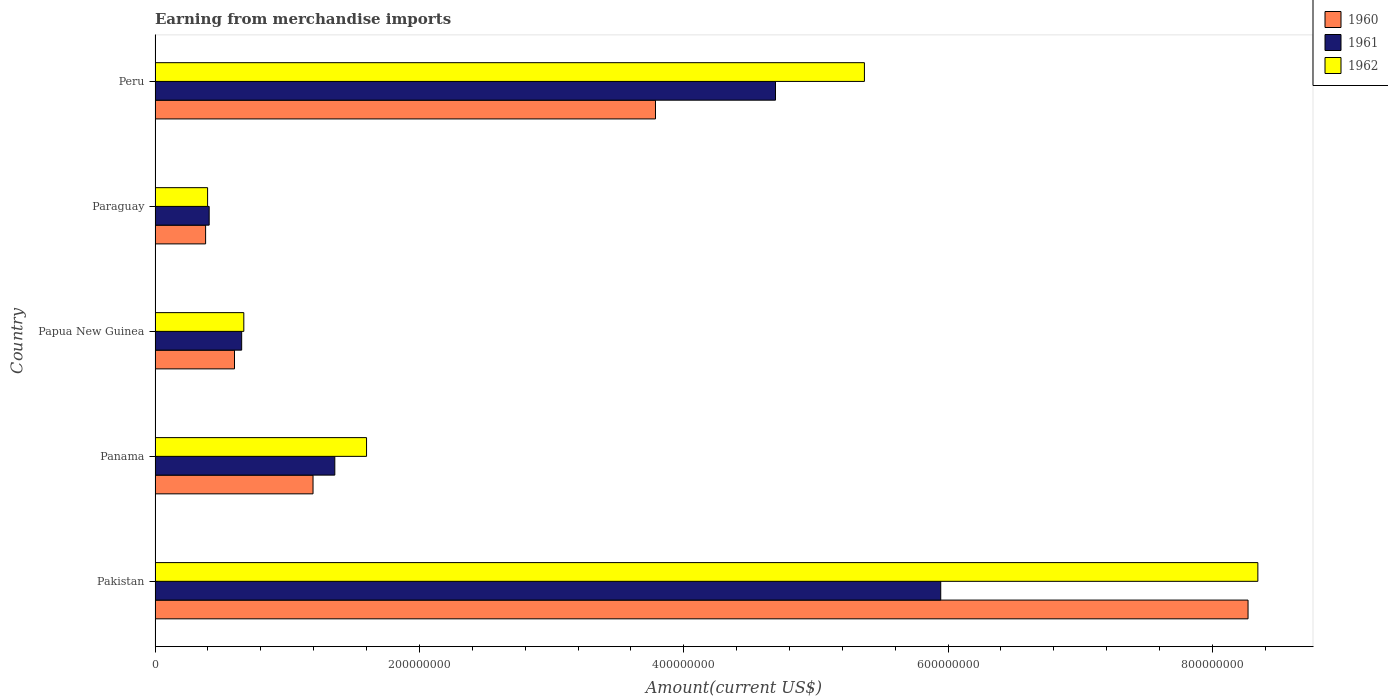How many different coloured bars are there?
Provide a short and direct response. 3. Are the number of bars per tick equal to the number of legend labels?
Give a very brief answer. Yes. How many bars are there on the 1st tick from the top?
Your response must be concise. 3. In how many cases, is the number of bars for a given country not equal to the number of legend labels?
Your answer should be very brief. 0. What is the amount earned from merchandise imports in 1960 in Papua New Guinea?
Offer a terse response. 6.01e+07. Across all countries, what is the maximum amount earned from merchandise imports in 1962?
Make the answer very short. 8.34e+08. Across all countries, what is the minimum amount earned from merchandise imports in 1960?
Ensure brevity in your answer.  3.82e+07. In which country was the amount earned from merchandise imports in 1962 minimum?
Keep it short and to the point. Paraguay. What is the total amount earned from merchandise imports in 1961 in the graph?
Your answer should be compact. 1.31e+09. What is the difference between the amount earned from merchandise imports in 1961 in Panama and that in Peru?
Make the answer very short. -3.33e+08. What is the difference between the amount earned from merchandise imports in 1960 in Panama and the amount earned from merchandise imports in 1962 in Paraguay?
Provide a succinct answer. 7.98e+07. What is the average amount earned from merchandise imports in 1961 per country?
Provide a short and direct response. 2.61e+08. What is the difference between the amount earned from merchandise imports in 1961 and amount earned from merchandise imports in 1960 in Papua New Guinea?
Give a very brief answer. 5.42e+06. What is the ratio of the amount earned from merchandise imports in 1960 in Panama to that in Peru?
Offer a terse response. 0.32. Is the difference between the amount earned from merchandise imports in 1961 in Pakistan and Panama greater than the difference between the amount earned from merchandise imports in 1960 in Pakistan and Panama?
Your answer should be very brief. No. What is the difference between the highest and the second highest amount earned from merchandise imports in 1962?
Offer a terse response. 2.98e+08. What is the difference between the highest and the lowest amount earned from merchandise imports in 1960?
Keep it short and to the point. 7.89e+08. What does the 1st bar from the top in Pakistan represents?
Offer a terse response. 1962. What does the 2nd bar from the bottom in Peru represents?
Your response must be concise. 1961. Is it the case that in every country, the sum of the amount earned from merchandise imports in 1960 and amount earned from merchandise imports in 1961 is greater than the amount earned from merchandise imports in 1962?
Your response must be concise. Yes. What is the difference between two consecutive major ticks on the X-axis?
Provide a short and direct response. 2.00e+08. Does the graph contain grids?
Your answer should be very brief. No. What is the title of the graph?
Your answer should be compact. Earning from merchandise imports. What is the label or title of the X-axis?
Provide a succinct answer. Amount(current US$). What is the Amount(current US$) in 1960 in Pakistan?
Your answer should be compact. 8.27e+08. What is the Amount(current US$) in 1961 in Pakistan?
Provide a succinct answer. 5.94e+08. What is the Amount(current US$) in 1962 in Pakistan?
Keep it short and to the point. 8.34e+08. What is the Amount(current US$) in 1960 in Panama?
Provide a succinct answer. 1.20e+08. What is the Amount(current US$) of 1961 in Panama?
Your response must be concise. 1.36e+08. What is the Amount(current US$) of 1962 in Panama?
Ensure brevity in your answer.  1.60e+08. What is the Amount(current US$) of 1960 in Papua New Guinea?
Provide a succinct answer. 6.01e+07. What is the Amount(current US$) of 1961 in Papua New Guinea?
Give a very brief answer. 6.55e+07. What is the Amount(current US$) of 1962 in Papua New Guinea?
Offer a terse response. 6.71e+07. What is the Amount(current US$) of 1960 in Paraguay?
Your answer should be very brief. 3.82e+07. What is the Amount(current US$) in 1961 in Paraguay?
Ensure brevity in your answer.  4.09e+07. What is the Amount(current US$) of 1962 in Paraguay?
Keep it short and to the point. 3.97e+07. What is the Amount(current US$) of 1960 in Peru?
Ensure brevity in your answer.  3.79e+08. What is the Amount(current US$) of 1961 in Peru?
Provide a short and direct response. 4.69e+08. What is the Amount(current US$) in 1962 in Peru?
Your answer should be compact. 5.37e+08. Across all countries, what is the maximum Amount(current US$) of 1960?
Keep it short and to the point. 8.27e+08. Across all countries, what is the maximum Amount(current US$) of 1961?
Your answer should be very brief. 5.94e+08. Across all countries, what is the maximum Amount(current US$) of 1962?
Offer a terse response. 8.34e+08. Across all countries, what is the minimum Amount(current US$) in 1960?
Give a very brief answer. 3.82e+07. Across all countries, what is the minimum Amount(current US$) in 1961?
Your response must be concise. 4.09e+07. Across all countries, what is the minimum Amount(current US$) of 1962?
Make the answer very short. 3.97e+07. What is the total Amount(current US$) in 1960 in the graph?
Give a very brief answer. 1.42e+09. What is the total Amount(current US$) of 1961 in the graph?
Provide a short and direct response. 1.31e+09. What is the total Amount(current US$) in 1962 in the graph?
Offer a very short reply. 1.64e+09. What is the difference between the Amount(current US$) of 1960 in Pakistan and that in Panama?
Your answer should be compact. 7.07e+08. What is the difference between the Amount(current US$) of 1961 in Pakistan and that in Panama?
Make the answer very short. 4.58e+08. What is the difference between the Amount(current US$) of 1962 in Pakistan and that in Panama?
Provide a short and direct response. 6.74e+08. What is the difference between the Amount(current US$) in 1960 in Pakistan and that in Papua New Guinea?
Your answer should be very brief. 7.67e+08. What is the difference between the Amount(current US$) in 1961 in Pakistan and that in Papua New Guinea?
Give a very brief answer. 5.29e+08. What is the difference between the Amount(current US$) of 1962 in Pakistan and that in Papua New Guinea?
Give a very brief answer. 7.67e+08. What is the difference between the Amount(current US$) in 1960 in Pakistan and that in Paraguay?
Your answer should be compact. 7.89e+08. What is the difference between the Amount(current US$) in 1961 in Pakistan and that in Paraguay?
Give a very brief answer. 5.53e+08. What is the difference between the Amount(current US$) of 1962 in Pakistan and that in Paraguay?
Your response must be concise. 7.95e+08. What is the difference between the Amount(current US$) in 1960 in Pakistan and that in Peru?
Offer a very short reply. 4.48e+08. What is the difference between the Amount(current US$) in 1961 in Pakistan and that in Peru?
Your answer should be compact. 1.25e+08. What is the difference between the Amount(current US$) of 1962 in Pakistan and that in Peru?
Offer a terse response. 2.98e+08. What is the difference between the Amount(current US$) in 1960 in Panama and that in Papua New Guinea?
Offer a very short reply. 5.94e+07. What is the difference between the Amount(current US$) in 1961 in Panama and that in Papua New Guinea?
Offer a very short reply. 7.05e+07. What is the difference between the Amount(current US$) of 1962 in Panama and that in Papua New Guinea?
Your response must be concise. 9.29e+07. What is the difference between the Amount(current US$) in 1960 in Panama and that in Paraguay?
Provide a succinct answer. 8.13e+07. What is the difference between the Amount(current US$) in 1961 in Panama and that in Paraguay?
Give a very brief answer. 9.51e+07. What is the difference between the Amount(current US$) of 1962 in Panama and that in Paraguay?
Your answer should be very brief. 1.20e+08. What is the difference between the Amount(current US$) in 1960 in Panama and that in Peru?
Give a very brief answer. -2.59e+08. What is the difference between the Amount(current US$) of 1961 in Panama and that in Peru?
Offer a very short reply. -3.33e+08. What is the difference between the Amount(current US$) of 1962 in Panama and that in Peru?
Keep it short and to the point. -3.77e+08. What is the difference between the Amount(current US$) in 1960 in Papua New Guinea and that in Paraguay?
Offer a terse response. 2.19e+07. What is the difference between the Amount(current US$) in 1961 in Papua New Guinea and that in Paraguay?
Your answer should be compact. 2.46e+07. What is the difference between the Amount(current US$) in 1962 in Papua New Guinea and that in Paraguay?
Provide a short and direct response. 2.74e+07. What is the difference between the Amount(current US$) in 1960 in Papua New Guinea and that in Peru?
Provide a succinct answer. -3.18e+08. What is the difference between the Amount(current US$) in 1961 in Papua New Guinea and that in Peru?
Give a very brief answer. -4.04e+08. What is the difference between the Amount(current US$) in 1962 in Papua New Guinea and that in Peru?
Give a very brief answer. -4.70e+08. What is the difference between the Amount(current US$) in 1960 in Paraguay and that in Peru?
Offer a terse response. -3.40e+08. What is the difference between the Amount(current US$) in 1961 in Paraguay and that in Peru?
Keep it short and to the point. -4.28e+08. What is the difference between the Amount(current US$) of 1962 in Paraguay and that in Peru?
Your answer should be compact. -4.97e+08. What is the difference between the Amount(current US$) in 1960 in Pakistan and the Amount(current US$) in 1961 in Panama?
Ensure brevity in your answer.  6.91e+08. What is the difference between the Amount(current US$) in 1960 in Pakistan and the Amount(current US$) in 1962 in Panama?
Keep it short and to the point. 6.67e+08. What is the difference between the Amount(current US$) of 1961 in Pakistan and the Amount(current US$) of 1962 in Panama?
Give a very brief answer. 4.34e+08. What is the difference between the Amount(current US$) in 1960 in Pakistan and the Amount(current US$) in 1961 in Papua New Guinea?
Make the answer very short. 7.61e+08. What is the difference between the Amount(current US$) of 1960 in Pakistan and the Amount(current US$) of 1962 in Papua New Guinea?
Provide a succinct answer. 7.60e+08. What is the difference between the Amount(current US$) of 1961 in Pakistan and the Amount(current US$) of 1962 in Papua New Guinea?
Provide a short and direct response. 5.27e+08. What is the difference between the Amount(current US$) of 1960 in Pakistan and the Amount(current US$) of 1961 in Paraguay?
Keep it short and to the point. 7.86e+08. What is the difference between the Amount(current US$) of 1960 in Pakistan and the Amount(current US$) of 1962 in Paraguay?
Provide a succinct answer. 7.87e+08. What is the difference between the Amount(current US$) in 1961 in Pakistan and the Amount(current US$) in 1962 in Paraguay?
Your response must be concise. 5.55e+08. What is the difference between the Amount(current US$) of 1960 in Pakistan and the Amount(current US$) of 1961 in Peru?
Your response must be concise. 3.58e+08. What is the difference between the Amount(current US$) in 1960 in Pakistan and the Amount(current US$) in 1962 in Peru?
Your response must be concise. 2.90e+08. What is the difference between the Amount(current US$) in 1961 in Pakistan and the Amount(current US$) in 1962 in Peru?
Keep it short and to the point. 5.77e+07. What is the difference between the Amount(current US$) in 1960 in Panama and the Amount(current US$) in 1961 in Papua New Guinea?
Offer a terse response. 5.40e+07. What is the difference between the Amount(current US$) in 1960 in Panama and the Amount(current US$) in 1962 in Papua New Guinea?
Ensure brevity in your answer.  5.24e+07. What is the difference between the Amount(current US$) of 1961 in Panama and the Amount(current US$) of 1962 in Papua New Guinea?
Provide a short and direct response. 6.89e+07. What is the difference between the Amount(current US$) of 1960 in Panama and the Amount(current US$) of 1961 in Paraguay?
Provide a succinct answer. 7.86e+07. What is the difference between the Amount(current US$) in 1960 in Panama and the Amount(current US$) in 1962 in Paraguay?
Make the answer very short. 7.98e+07. What is the difference between the Amount(current US$) in 1961 in Panama and the Amount(current US$) in 1962 in Paraguay?
Make the answer very short. 9.63e+07. What is the difference between the Amount(current US$) of 1960 in Panama and the Amount(current US$) of 1961 in Peru?
Your answer should be compact. -3.50e+08. What is the difference between the Amount(current US$) of 1960 in Panama and the Amount(current US$) of 1962 in Peru?
Offer a terse response. -4.17e+08. What is the difference between the Amount(current US$) in 1961 in Panama and the Amount(current US$) in 1962 in Peru?
Provide a succinct answer. -4.01e+08. What is the difference between the Amount(current US$) in 1960 in Papua New Guinea and the Amount(current US$) in 1961 in Paraguay?
Offer a terse response. 1.92e+07. What is the difference between the Amount(current US$) of 1960 in Papua New Guinea and the Amount(current US$) of 1962 in Paraguay?
Provide a succinct answer. 2.04e+07. What is the difference between the Amount(current US$) of 1961 in Papua New Guinea and the Amount(current US$) of 1962 in Paraguay?
Offer a terse response. 2.58e+07. What is the difference between the Amount(current US$) of 1960 in Papua New Guinea and the Amount(current US$) of 1961 in Peru?
Your response must be concise. -4.09e+08. What is the difference between the Amount(current US$) in 1960 in Papua New Guinea and the Amount(current US$) in 1962 in Peru?
Provide a short and direct response. -4.77e+08. What is the difference between the Amount(current US$) in 1961 in Papua New Guinea and the Amount(current US$) in 1962 in Peru?
Your response must be concise. -4.71e+08. What is the difference between the Amount(current US$) of 1960 in Paraguay and the Amount(current US$) of 1961 in Peru?
Provide a succinct answer. -4.31e+08. What is the difference between the Amount(current US$) in 1960 in Paraguay and the Amount(current US$) in 1962 in Peru?
Your response must be concise. -4.98e+08. What is the difference between the Amount(current US$) of 1961 in Paraguay and the Amount(current US$) of 1962 in Peru?
Offer a terse response. -4.96e+08. What is the average Amount(current US$) in 1960 per country?
Your answer should be very brief. 2.85e+08. What is the average Amount(current US$) in 1961 per country?
Provide a short and direct response. 2.61e+08. What is the average Amount(current US$) in 1962 per country?
Your response must be concise. 3.28e+08. What is the difference between the Amount(current US$) of 1960 and Amount(current US$) of 1961 in Pakistan?
Give a very brief answer. 2.33e+08. What is the difference between the Amount(current US$) in 1960 and Amount(current US$) in 1962 in Pakistan?
Give a very brief answer. -7.41e+06. What is the difference between the Amount(current US$) in 1961 and Amount(current US$) in 1962 in Pakistan?
Offer a very short reply. -2.40e+08. What is the difference between the Amount(current US$) of 1960 and Amount(current US$) of 1961 in Panama?
Provide a succinct answer. -1.65e+07. What is the difference between the Amount(current US$) in 1960 and Amount(current US$) in 1962 in Panama?
Give a very brief answer. -4.05e+07. What is the difference between the Amount(current US$) of 1961 and Amount(current US$) of 1962 in Panama?
Provide a short and direct response. -2.40e+07. What is the difference between the Amount(current US$) of 1960 and Amount(current US$) of 1961 in Papua New Guinea?
Provide a succinct answer. -5.42e+06. What is the difference between the Amount(current US$) of 1960 and Amount(current US$) of 1962 in Papua New Guinea?
Provide a succinct answer. -7.04e+06. What is the difference between the Amount(current US$) of 1961 and Amount(current US$) of 1962 in Papua New Guinea?
Your response must be concise. -1.62e+06. What is the difference between the Amount(current US$) in 1960 and Amount(current US$) in 1961 in Paraguay?
Give a very brief answer. -2.70e+06. What is the difference between the Amount(current US$) of 1960 and Amount(current US$) of 1962 in Paraguay?
Offer a terse response. -1.50e+06. What is the difference between the Amount(current US$) in 1961 and Amount(current US$) in 1962 in Paraguay?
Offer a very short reply. 1.20e+06. What is the difference between the Amount(current US$) in 1960 and Amount(current US$) in 1961 in Peru?
Your answer should be compact. -9.08e+07. What is the difference between the Amount(current US$) in 1960 and Amount(current US$) in 1962 in Peru?
Keep it short and to the point. -1.58e+08. What is the difference between the Amount(current US$) of 1961 and Amount(current US$) of 1962 in Peru?
Your answer should be compact. -6.73e+07. What is the ratio of the Amount(current US$) of 1960 in Pakistan to that in Panama?
Offer a very short reply. 6.92. What is the ratio of the Amount(current US$) in 1961 in Pakistan to that in Panama?
Offer a very short reply. 4.37. What is the ratio of the Amount(current US$) in 1962 in Pakistan to that in Panama?
Provide a short and direct response. 5.21. What is the ratio of the Amount(current US$) of 1960 in Pakistan to that in Papua New Guinea?
Offer a very short reply. 13.76. What is the ratio of the Amount(current US$) in 1961 in Pakistan to that in Papua New Guinea?
Your answer should be compact. 9.07. What is the ratio of the Amount(current US$) of 1962 in Pakistan to that in Papua New Guinea?
Your answer should be compact. 12.43. What is the ratio of the Amount(current US$) of 1960 in Pakistan to that in Paraguay?
Your answer should be very brief. 21.62. What is the ratio of the Amount(current US$) in 1961 in Pakistan to that in Paraguay?
Ensure brevity in your answer.  14.52. What is the ratio of the Amount(current US$) of 1962 in Pakistan to that in Paraguay?
Your response must be concise. 20.99. What is the ratio of the Amount(current US$) of 1960 in Pakistan to that in Peru?
Your response must be concise. 2.18. What is the ratio of the Amount(current US$) of 1961 in Pakistan to that in Peru?
Your answer should be very brief. 1.27. What is the ratio of the Amount(current US$) in 1962 in Pakistan to that in Peru?
Make the answer very short. 1.55. What is the ratio of the Amount(current US$) of 1960 in Panama to that in Papua New Guinea?
Provide a short and direct response. 1.99. What is the ratio of the Amount(current US$) in 1961 in Panama to that in Papua New Guinea?
Make the answer very short. 2.08. What is the ratio of the Amount(current US$) in 1962 in Panama to that in Papua New Guinea?
Keep it short and to the point. 2.38. What is the ratio of the Amount(current US$) of 1960 in Panama to that in Paraguay?
Offer a very short reply. 3.13. What is the ratio of the Amount(current US$) in 1961 in Panama to that in Paraguay?
Provide a short and direct response. 3.32. What is the ratio of the Amount(current US$) in 1962 in Panama to that in Paraguay?
Give a very brief answer. 4.03. What is the ratio of the Amount(current US$) of 1960 in Panama to that in Peru?
Offer a very short reply. 0.32. What is the ratio of the Amount(current US$) of 1961 in Panama to that in Peru?
Provide a succinct answer. 0.29. What is the ratio of the Amount(current US$) of 1962 in Panama to that in Peru?
Your answer should be very brief. 0.3. What is the ratio of the Amount(current US$) of 1960 in Papua New Guinea to that in Paraguay?
Give a very brief answer. 1.57. What is the ratio of the Amount(current US$) of 1961 in Papua New Guinea to that in Paraguay?
Offer a very short reply. 1.6. What is the ratio of the Amount(current US$) of 1962 in Papua New Guinea to that in Paraguay?
Your answer should be compact. 1.69. What is the ratio of the Amount(current US$) of 1960 in Papua New Guinea to that in Peru?
Offer a terse response. 0.16. What is the ratio of the Amount(current US$) of 1961 in Papua New Guinea to that in Peru?
Make the answer very short. 0.14. What is the ratio of the Amount(current US$) in 1962 in Papua New Guinea to that in Peru?
Make the answer very short. 0.13. What is the ratio of the Amount(current US$) of 1960 in Paraguay to that in Peru?
Offer a terse response. 0.1. What is the ratio of the Amount(current US$) of 1961 in Paraguay to that in Peru?
Provide a short and direct response. 0.09. What is the ratio of the Amount(current US$) in 1962 in Paraguay to that in Peru?
Provide a short and direct response. 0.07. What is the difference between the highest and the second highest Amount(current US$) in 1960?
Offer a very short reply. 4.48e+08. What is the difference between the highest and the second highest Amount(current US$) in 1961?
Your answer should be very brief. 1.25e+08. What is the difference between the highest and the second highest Amount(current US$) of 1962?
Make the answer very short. 2.98e+08. What is the difference between the highest and the lowest Amount(current US$) in 1960?
Provide a succinct answer. 7.89e+08. What is the difference between the highest and the lowest Amount(current US$) of 1961?
Provide a short and direct response. 5.53e+08. What is the difference between the highest and the lowest Amount(current US$) in 1962?
Offer a terse response. 7.95e+08. 